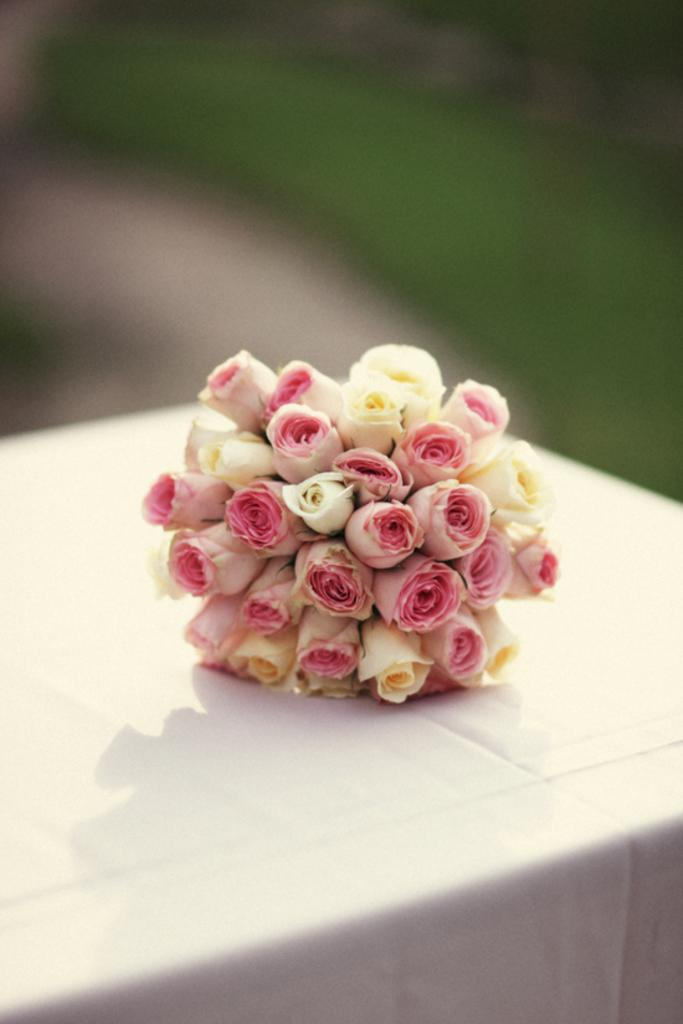What colors are the roses on the table in the image? The roses on the table are pink and yellow in color. What is covering the table in the image? The table is covered with a white color cloth. Can you describe the background of the image? The back of the image is blurry. What type of skirt is visible in the image? There is no skirt present in the image. How many eggs are on the table in the image? There are no eggs present in the image. 